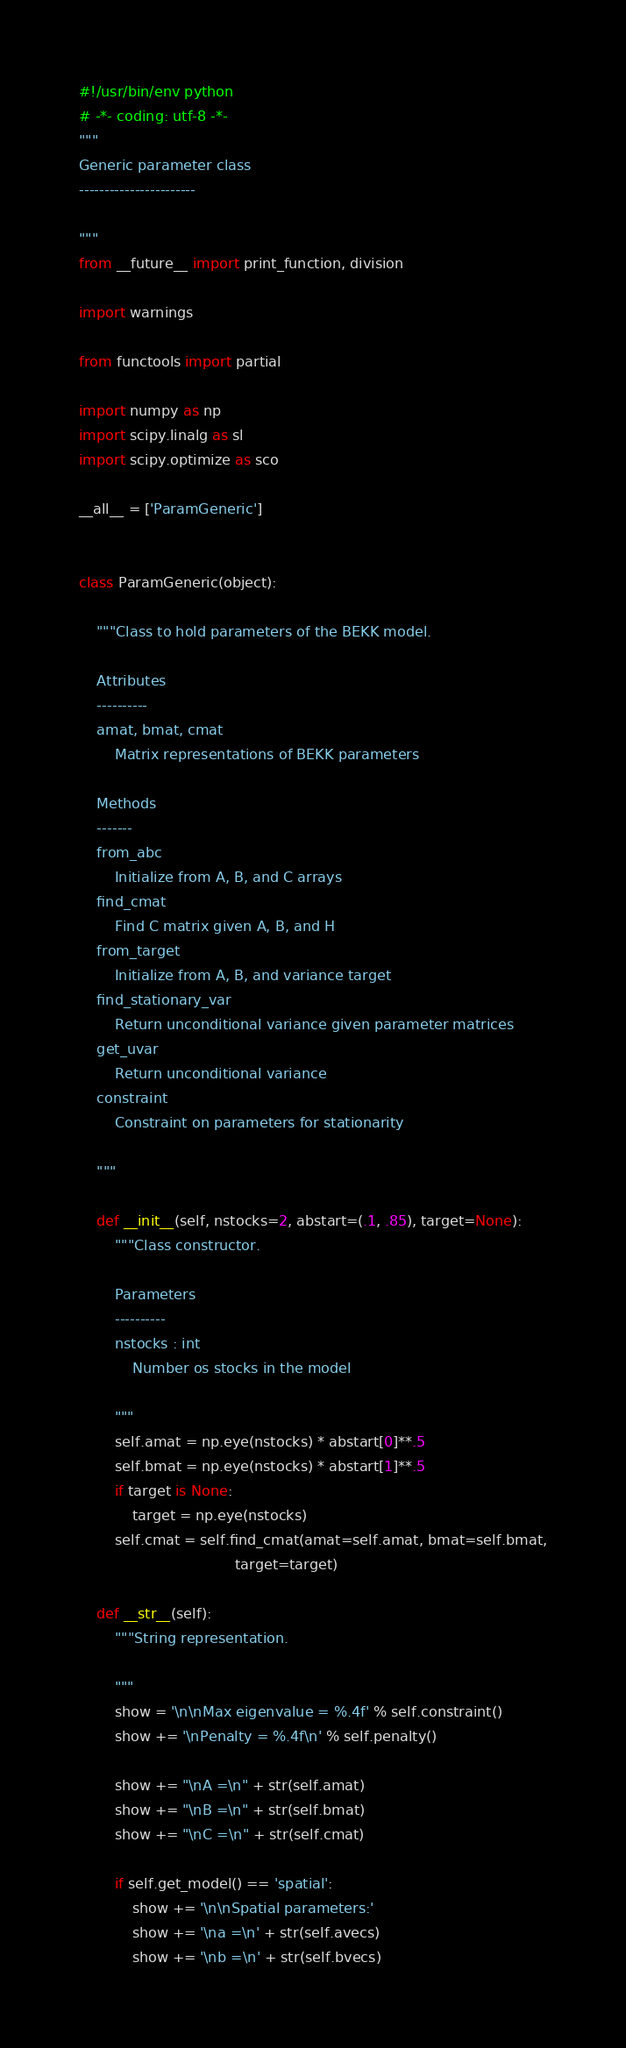<code> <loc_0><loc_0><loc_500><loc_500><_Python_>#!/usr/bin/env python
# -*- coding: utf-8 -*-
"""
Generic parameter class
-----------------------

"""
from __future__ import print_function, division

import warnings

from functools import partial

import numpy as np
import scipy.linalg as sl
import scipy.optimize as sco

__all__ = ['ParamGeneric']


class ParamGeneric(object):

    """Class to hold parameters of the BEKK model.

    Attributes
    ----------
    amat, bmat, cmat
        Matrix representations of BEKK parameters

    Methods
    -------
    from_abc
        Initialize from A, B, and C arrays
    find_cmat
        Find C matrix given A, B, and H
    from_target
        Initialize from A, B, and variance target
    find_stationary_var
        Return unconditional variance given parameter matrices
    get_uvar
        Return unconditional variance
    constraint
        Constraint on parameters for stationarity

    """

    def __init__(self, nstocks=2, abstart=(.1, .85), target=None):
        """Class constructor.

        Parameters
        ----------
        nstocks : int
            Number os stocks in the model

        """
        self.amat = np.eye(nstocks) * abstart[0]**.5
        self.bmat = np.eye(nstocks) * abstart[1]**.5
        if target is None:
            target = np.eye(nstocks)
        self.cmat = self.find_cmat(amat=self.amat, bmat=self.bmat,
                                   target=target)

    def __str__(self):
        """String representation.

        """
        show = '\n\nMax eigenvalue = %.4f' % self.constraint()
        show += '\nPenalty = %.4f\n' % self.penalty()

        show += "\nA =\n" + str(self.amat)
        show += "\nB =\n" + str(self.bmat)
        show += "\nC =\n" + str(self.cmat)

        if self.get_model() == 'spatial':
            show += '\n\nSpatial parameters:'
            show += '\na =\n' + str(self.avecs)
            show += '\nb =\n' + str(self.bvecs)</code> 